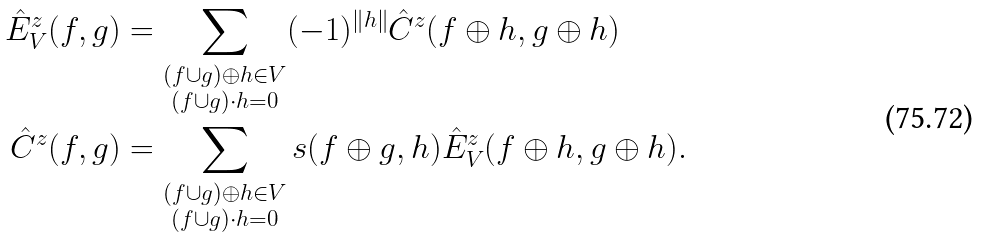<formula> <loc_0><loc_0><loc_500><loc_500>\hat { E } _ { V } ^ { z } ( f , g ) & = \sum _ { \substack { ( f \cup g ) \oplus h \in V \\ ( f \cup g ) \cdot h = 0 } } ( - 1 ) ^ { \| h \| } \hat { C } ^ { z } ( f \oplus h , g \oplus h ) \\ \hat { C } ^ { z } ( f , g ) & = \sum _ { \substack { ( f \cup g ) \oplus h \in V \\ ( f \cup g ) \cdot h = 0 } } s ( f \oplus g , h ) \hat { E } _ { V } ^ { z } ( f \oplus h , g \oplus h ) .</formula> 